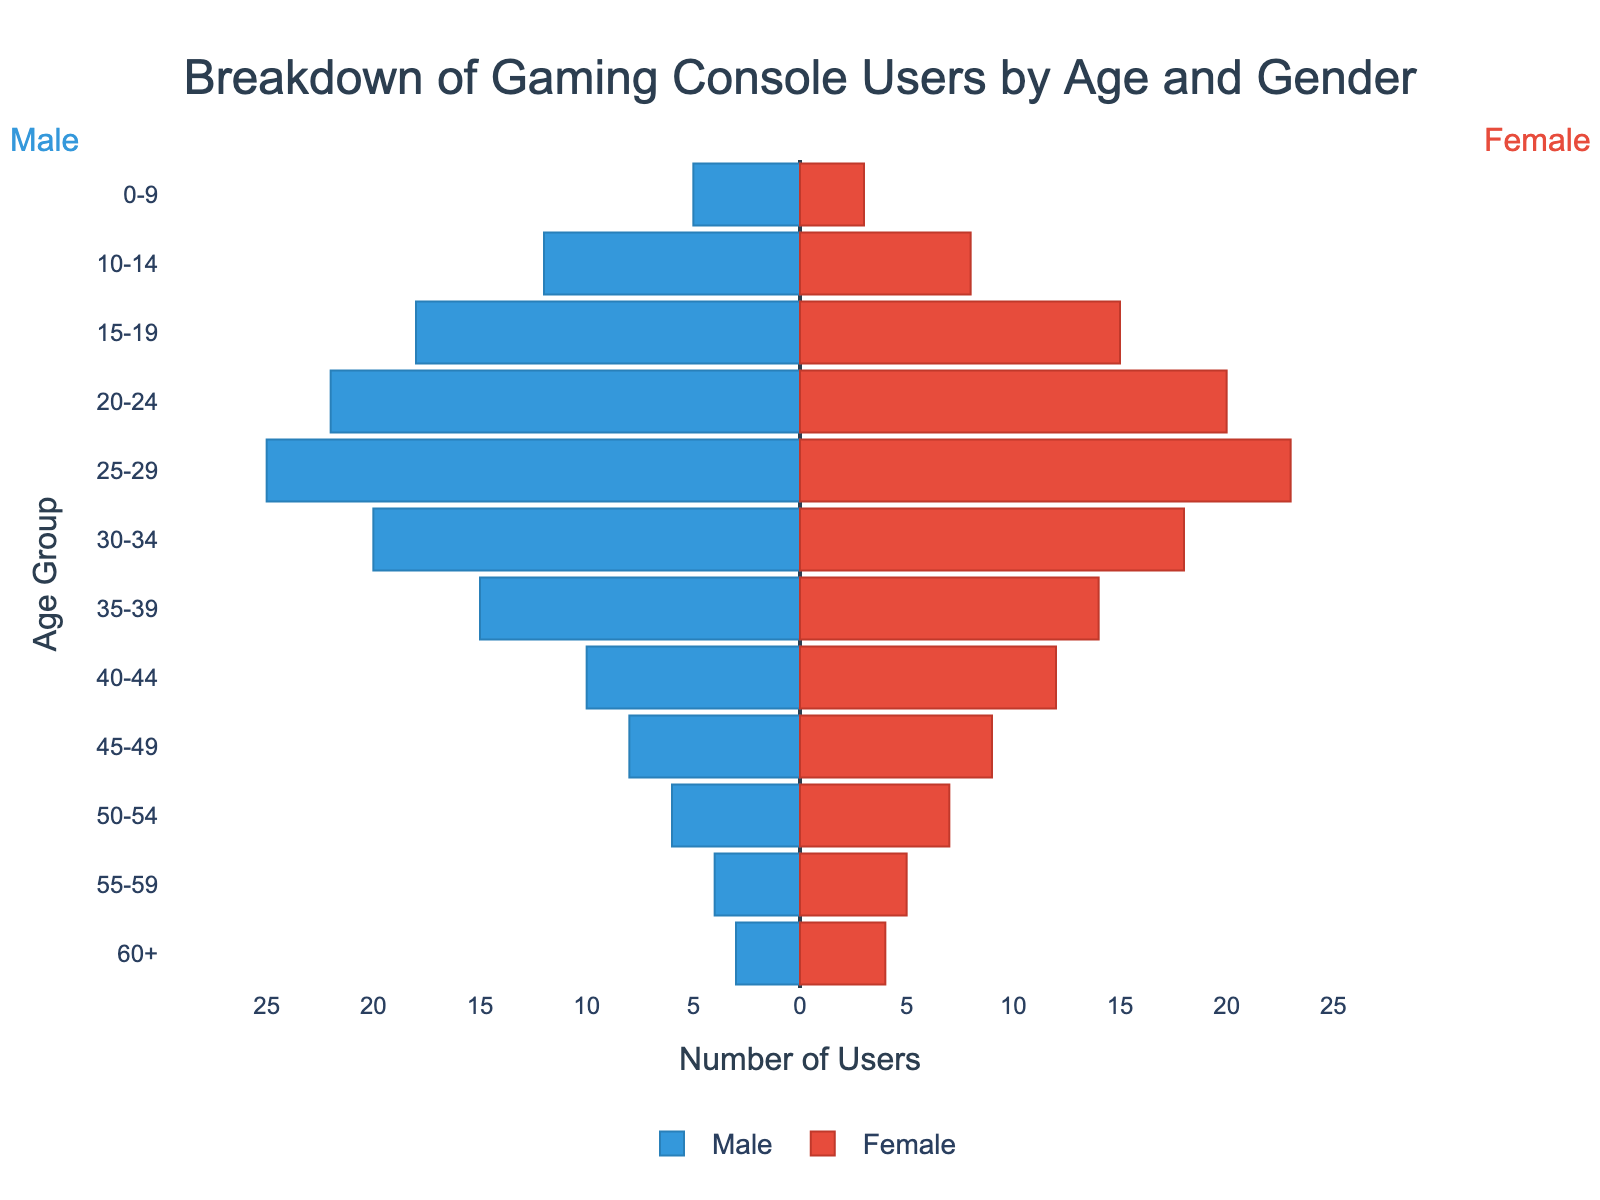What does the title of the plot say? The title is clearly mentioned at the top of the figure. It states, "Breakdown of Gaming Console Users by Age and Gender."
Answer: Breakdown of Gaming Console Users by Age and Gender What is the color used to represent male and female users? The bars representing males are colored in blue shades, while those representing females are colored in red shades.
Answer: Blue for males, red for females Which age group has the highest number of male users? To find the age group with the highest number of male users, compare the lengths of the blue bars. The longest blue bar corresponds to the 25-29 age group with 25 users.
Answer: 25-29 What is the total number of gaming console users aged 10-14? Sum the number of male and female users in the 10-14 age group: 12 (males) + 8 (females) = 20.
Answer: 20 In the age group 55-59, are there more male or female users? Compare the lengths of the blue and red bars for the 55-59 age group. The red bar (female) is slightly longer, indicating 5 female users compared to 4 male users.
Answer: Female Which age group shows an equal number of male and female users? Look for age groups where the lengths of the blue and red bars are equal. The age group 20-24 has 22 male users and 20 female users, which is not equal. There is no exact equal count in any age group.
Answer: None What is the difference in the number of male and female users in the 40-44 age group? Subtract the number of male users from the number of female users in the 40-44 age group: 12 (females) - 10 (males) = 2.
Answer: 2 How do the number of users in the 25-29 age group compare to users in the 30-34 age group? Compare the sum of male and female users in both age groups. For 25-29: 25 (males) + 23 (females) = 48. For 30-34: 20 (males) + 18 (females) = 38. Thus, 25-29 has 10 more users than 30-34.
Answer: 25-29 has 10 more users Which gender is more prominent in the 0-9 age group? Compare the bars for males and females in the 0-9 age group. The blue bar (males) is longer than the red bar (females), indicating there are 5 male users and 3 female users.
Answer: Male What is the total user count in the age range of 20-29? Add the number of users (both male and female) in the age groups 20-24 and 25-29. For 20-24: 22 (males) + 20 (females) = 42. For 25-29: 25 (males) + 23 (females) = 48. Total: 42 + 48 = 90.
Answer: 90 